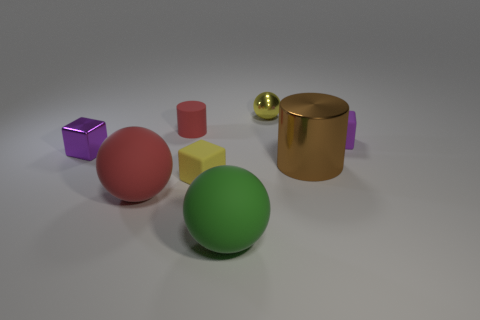Add 1 tiny yellow balls. How many objects exist? 9 Subtract all tiny yellow spheres. How many spheres are left? 2 Subtract 1 cubes. How many cubes are left? 2 Subtract all cylinders. How many objects are left? 6 Subtract all red spheres. How many spheres are left? 2 Subtract 0 brown spheres. How many objects are left? 8 Subtract all brown cylinders. Subtract all cyan blocks. How many cylinders are left? 1 Subtract all purple spheres. How many purple cylinders are left? 0 Subtract all purple objects. Subtract all red cylinders. How many objects are left? 5 Add 2 tiny yellow objects. How many tiny yellow objects are left? 4 